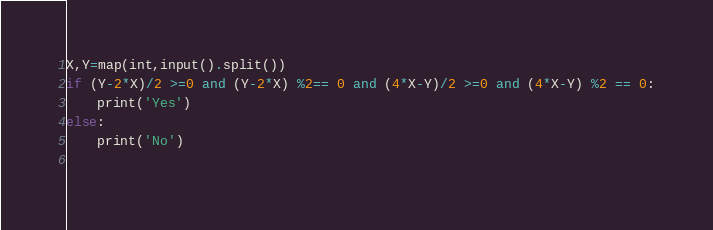Convert code to text. <code><loc_0><loc_0><loc_500><loc_500><_Python_>X,Y=map(int,input().split())
if (Y-2*X)/2 >=0 and (Y-2*X) %2== 0 and (4*X-Y)/2 >=0 and (4*X-Y) %2 == 0:
    print('Yes')
else:
    print('No')
    </code> 